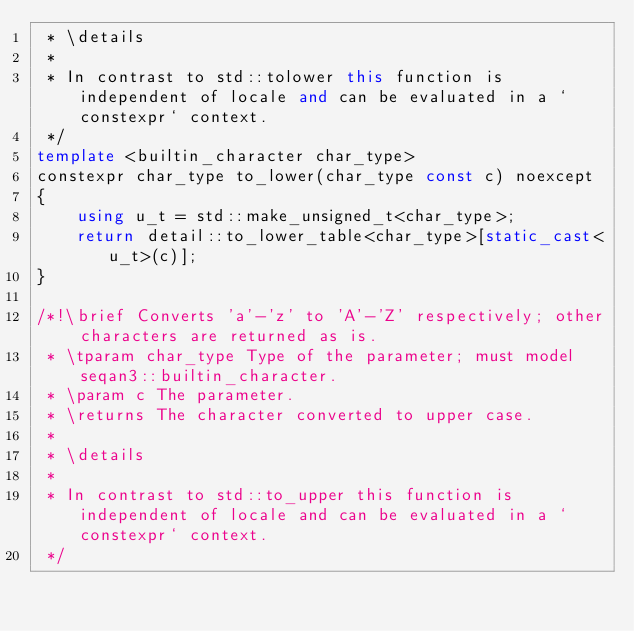Convert code to text. <code><loc_0><loc_0><loc_500><loc_500><_C++_> * \details
 *
 * In contrast to std::tolower this function is independent of locale and can be evaluated in a `constexpr` context.
 */
template <builtin_character char_type>
constexpr char_type to_lower(char_type const c) noexcept
{
    using u_t = std::make_unsigned_t<char_type>;
    return detail::to_lower_table<char_type>[static_cast<u_t>(c)];
}

/*!\brief Converts 'a'-'z' to 'A'-'Z' respectively; other characters are returned as is.
 * \tparam char_type Type of the parameter; must model seqan3::builtin_character.
 * \param c The parameter.
 * \returns The character converted to upper case.
 *
 * \details
 *
 * In contrast to std::to_upper this function is independent of locale and can be evaluated in a `constexpr` context.
 */</code> 